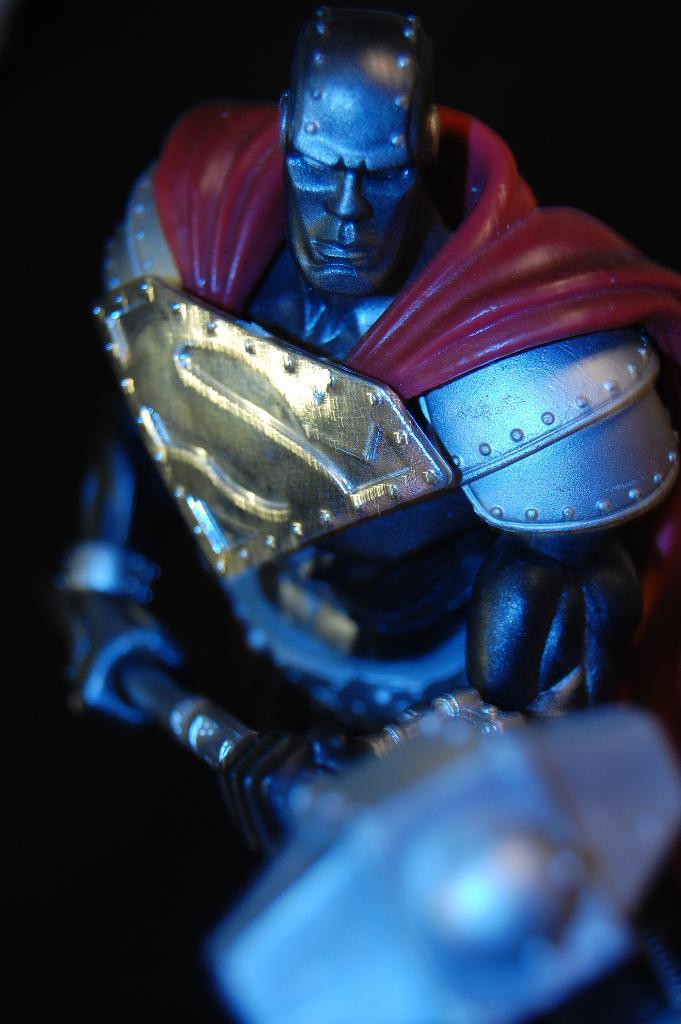What object can be seen in the image? There is a toy in the image. What is the toy holding? The toy is holding a hammer. How many wings does the toy have in the image? The toy does not have any wings in the image. What type of bee can be seen interacting with the toy in the image? There is no bee present in the image; it only features a toy holding a hammer. 